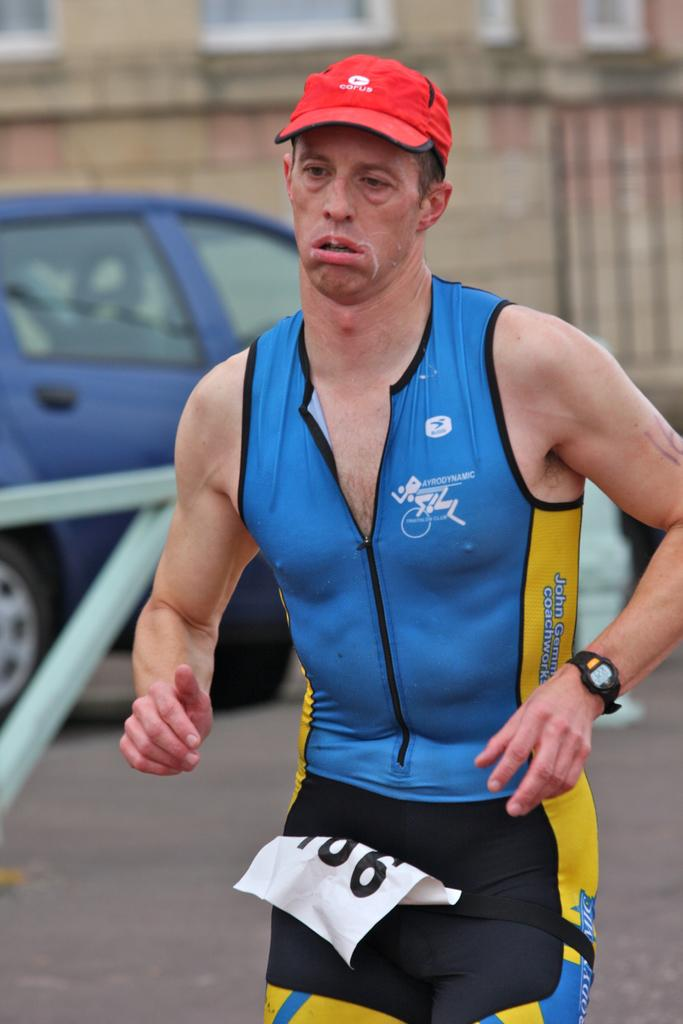<image>
Provide a brief description of the given image. A man in a red cap and a blue and yellow running outfit and the number 106 printed on a paper on his person. 